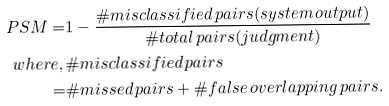<formula> <loc_0><loc_0><loc_500><loc_500>P S M = & 1 - \frac { \# m i s c l a s s i f i e d \, p a i r s ( s y s t e m \, o u t p u t ) } { \# t o t a l \, p a i r s ( j u d g m e n t ) } \\ w h e r e , \, & \# m i s c l a s s i f i e d \, p a i r s \\ = & \# m i s s e d \, p a i r s + \# f a l s e \, o v e r l a p p i n g \, p a i r s . \\</formula> 